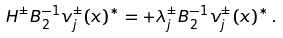Convert formula to latex. <formula><loc_0><loc_0><loc_500><loc_500>H ^ { \pm } B _ { 2 } ^ { - 1 } v _ { j } ^ { \pm } ( x ) ^ { * } = + \lambda _ { j } ^ { \pm } B _ { 2 } ^ { - 1 } v _ { j } ^ { \pm } ( x ) ^ { * } \, .</formula> 